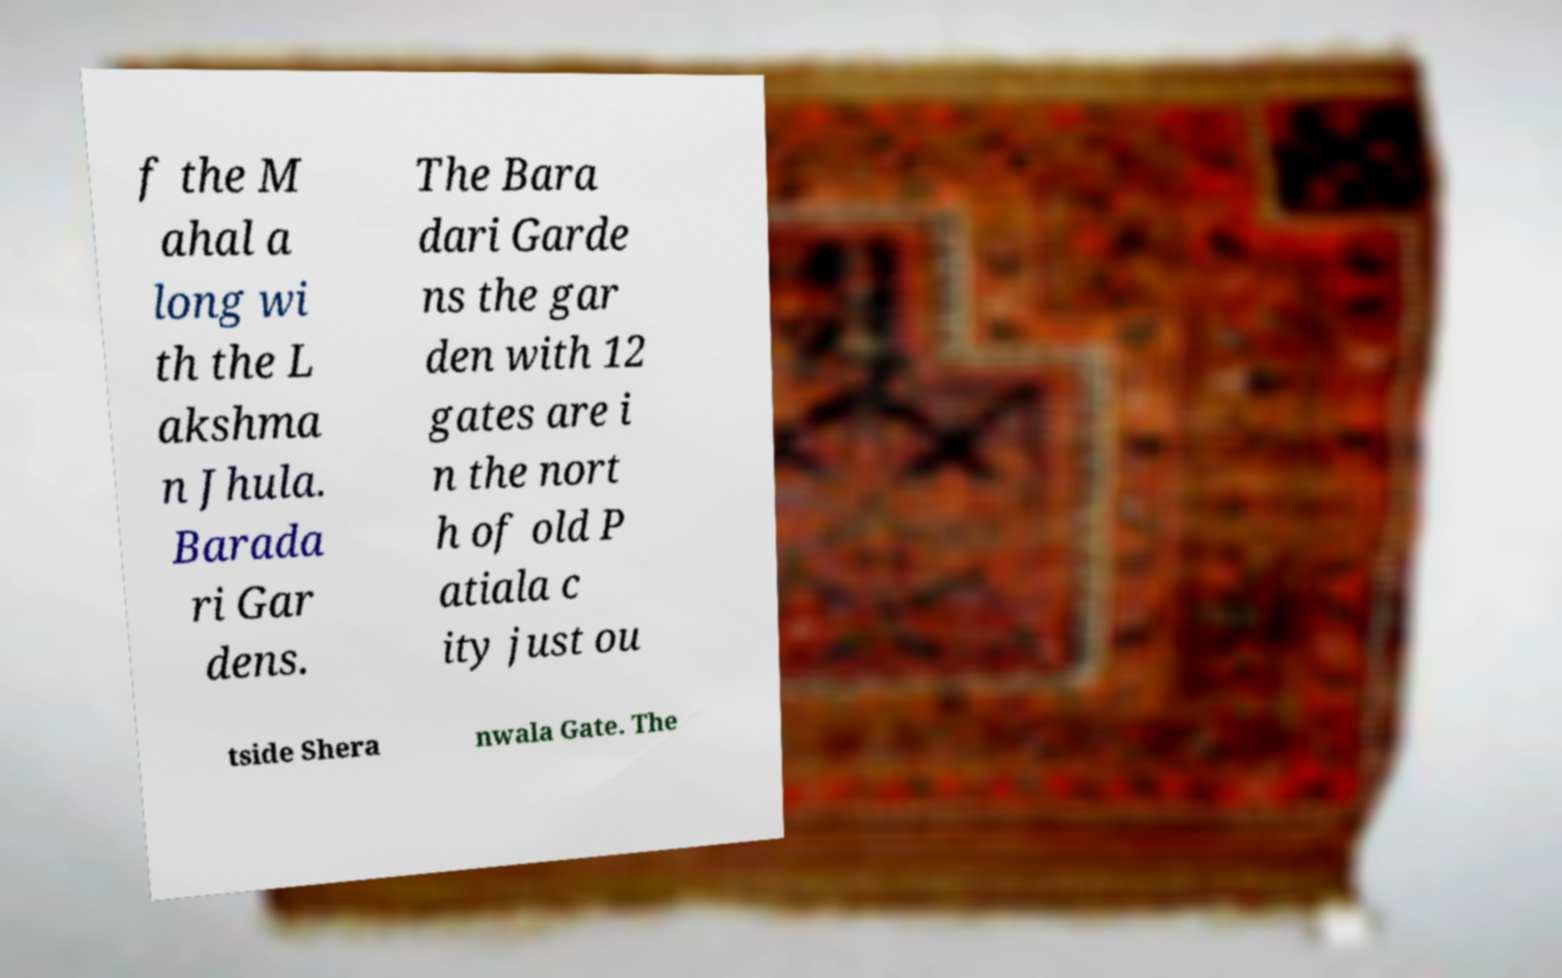I need the written content from this picture converted into text. Can you do that? f the M ahal a long wi th the L akshma n Jhula. Barada ri Gar dens. The Bara dari Garde ns the gar den with 12 gates are i n the nort h of old P atiala c ity just ou tside Shera nwala Gate. The 